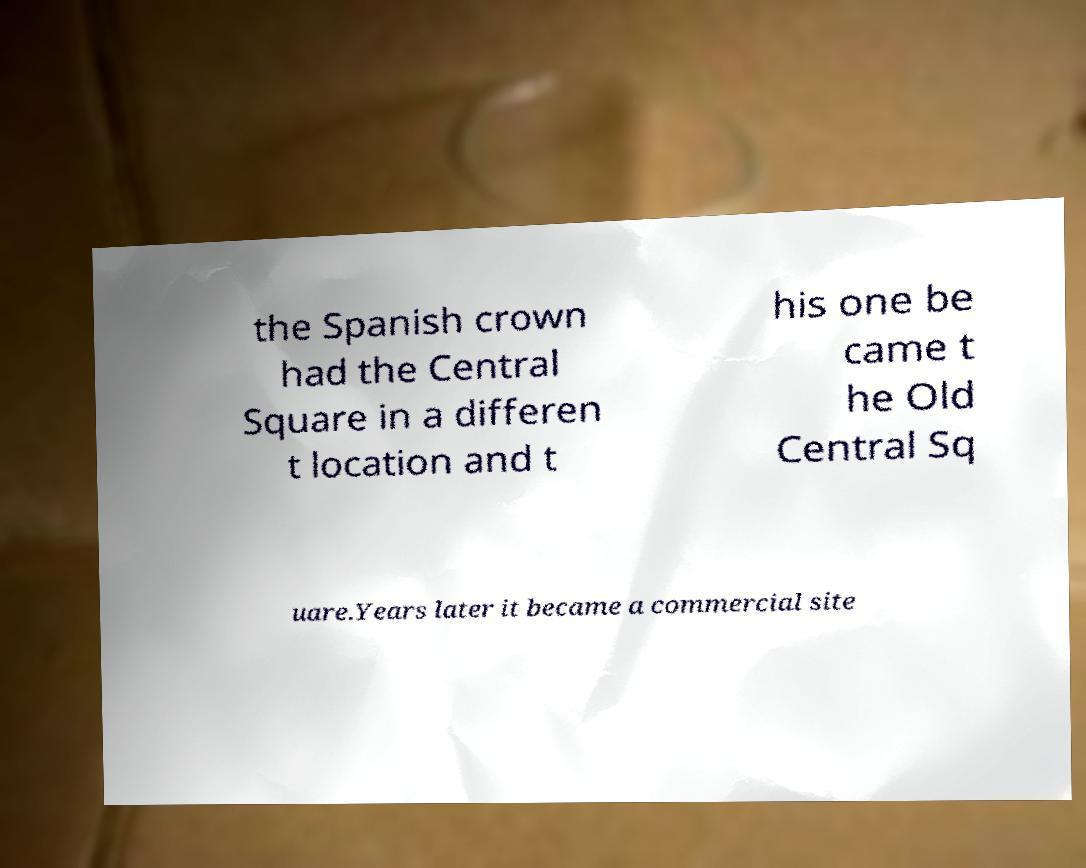I need the written content from this picture converted into text. Can you do that? the Spanish crown had the Central Square in a differen t location and t his one be came t he Old Central Sq uare.Years later it became a commercial site 